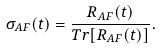<formula> <loc_0><loc_0><loc_500><loc_500>\sigma _ { A F } ( t ) = \frac { R _ { A F } ( t ) } { T r [ R _ { A F } ( t ) ] } .</formula> 